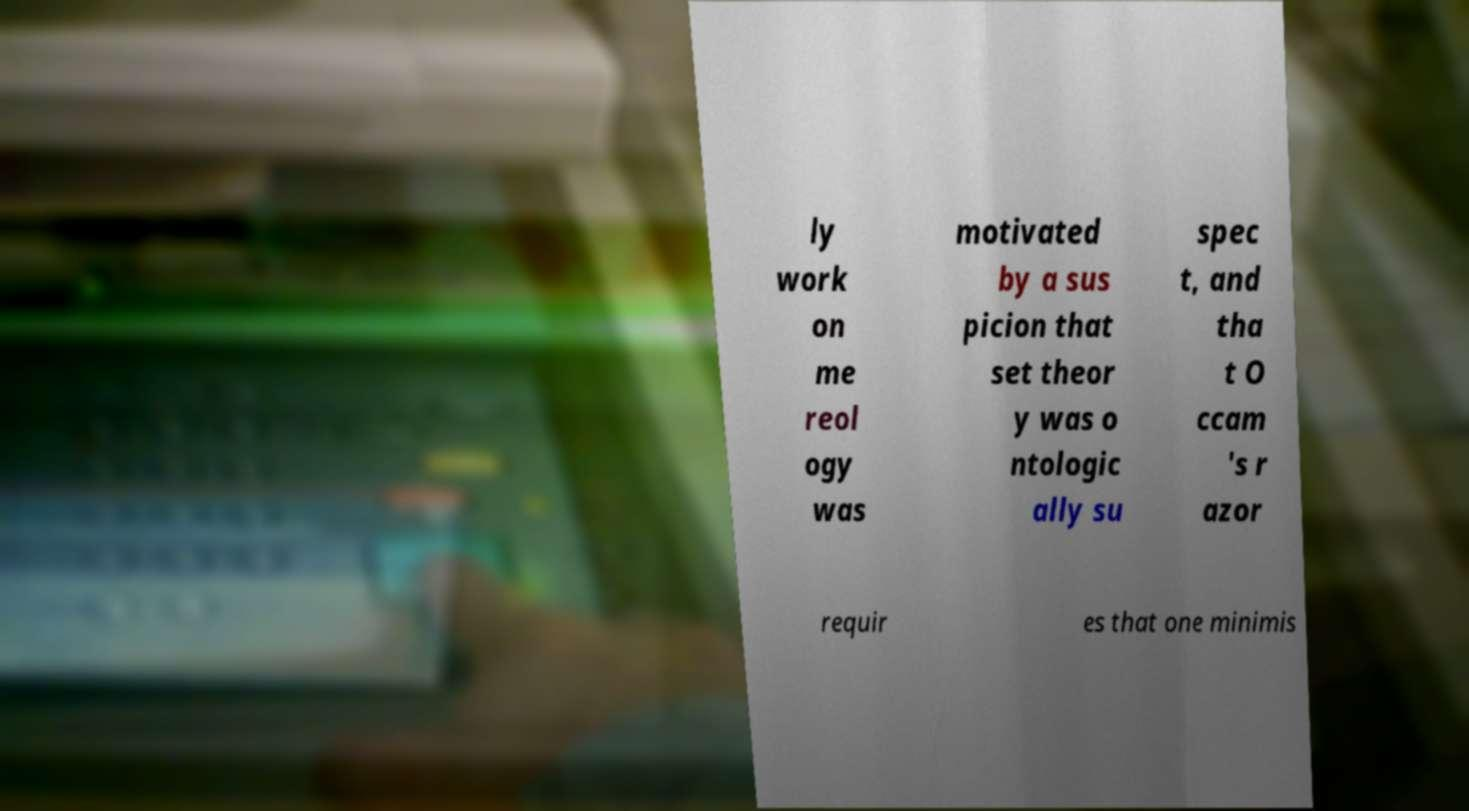Can you accurately transcribe the text from the provided image for me? ly work on me reol ogy was motivated by a sus picion that set theor y was o ntologic ally su spec t, and tha t O ccam 's r azor requir es that one minimis 